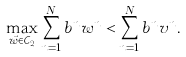Convert formula to latex. <formula><loc_0><loc_0><loc_500><loc_500>\max _ { \vec { w } \in \mathcal { C } _ { 2 } } \sum _ { n = 1 } ^ { N } b ^ { n } w ^ { n } < \sum _ { n = 1 } ^ { N } b ^ { n } v ^ { n } .</formula> 